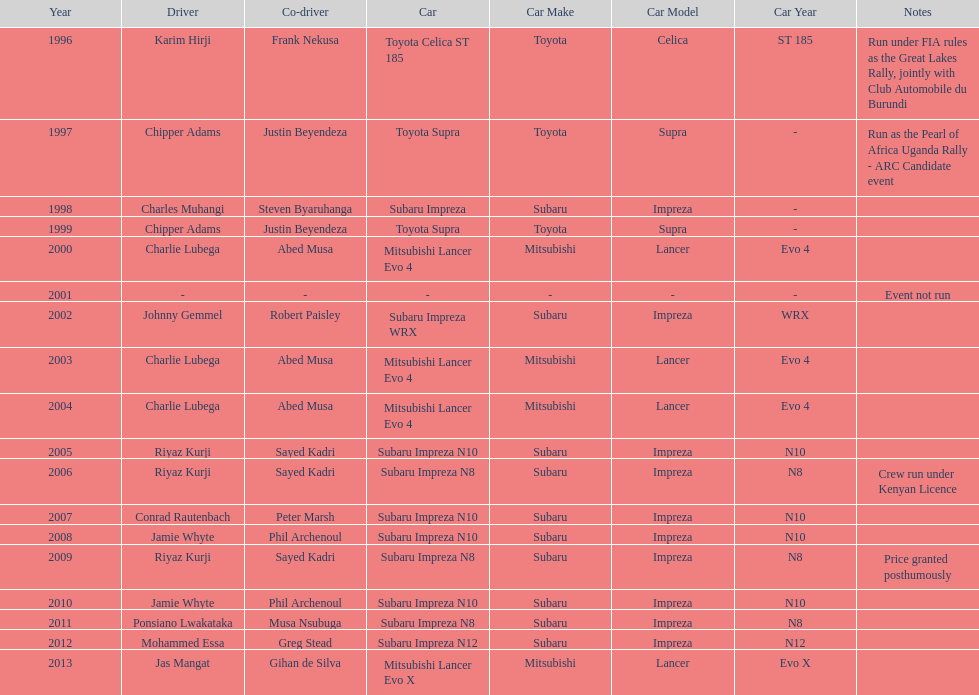How many drivers have achieved victory at least two times? 4. 